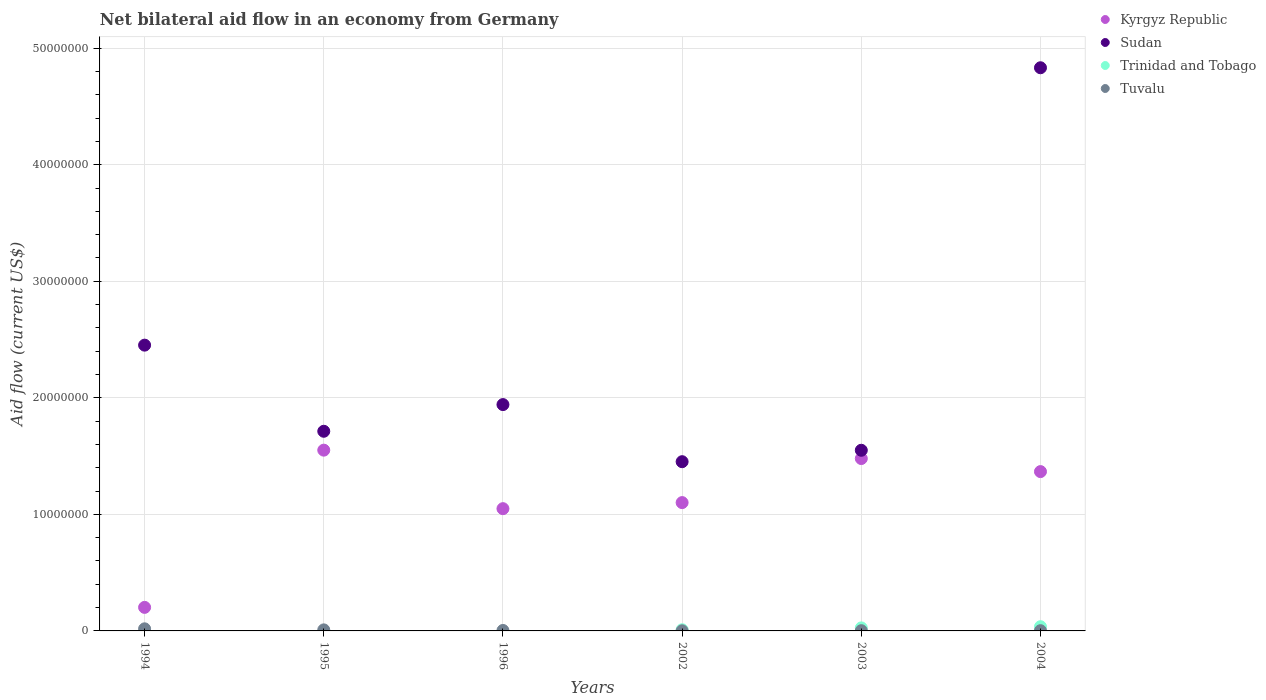Is the number of dotlines equal to the number of legend labels?
Provide a succinct answer. No. What is the net bilateral aid flow in Kyrgyz Republic in 2004?
Your answer should be very brief. 1.37e+07. Across all years, what is the maximum net bilateral aid flow in Sudan?
Give a very brief answer. 4.83e+07. Across all years, what is the minimum net bilateral aid flow in Kyrgyz Republic?
Keep it short and to the point. 2.02e+06. In which year was the net bilateral aid flow in Tuvalu maximum?
Provide a succinct answer. 1994. What is the difference between the net bilateral aid flow in Tuvalu in 2003 and that in 2004?
Your answer should be compact. 0. What is the difference between the net bilateral aid flow in Tuvalu in 1994 and the net bilateral aid flow in Sudan in 1996?
Offer a terse response. -1.92e+07. What is the average net bilateral aid flow in Sudan per year?
Give a very brief answer. 2.32e+07. In the year 1995, what is the difference between the net bilateral aid flow in Tuvalu and net bilateral aid flow in Sudan?
Your answer should be compact. -1.70e+07. What is the ratio of the net bilateral aid flow in Trinidad and Tobago in 2002 to that in 2004?
Your answer should be very brief. 0.28. Is the net bilateral aid flow in Sudan in 1995 less than that in 2003?
Offer a terse response. No. What is the difference between the highest and the second highest net bilateral aid flow in Sudan?
Your response must be concise. 2.38e+07. Is the sum of the net bilateral aid flow in Sudan in 1996 and 2004 greater than the maximum net bilateral aid flow in Trinidad and Tobago across all years?
Give a very brief answer. Yes. Does the net bilateral aid flow in Kyrgyz Republic monotonically increase over the years?
Offer a very short reply. No. Is the net bilateral aid flow in Tuvalu strictly less than the net bilateral aid flow in Trinidad and Tobago over the years?
Offer a very short reply. No. How many dotlines are there?
Provide a succinct answer. 4. How many years are there in the graph?
Your answer should be compact. 6. Where does the legend appear in the graph?
Keep it short and to the point. Top right. What is the title of the graph?
Your answer should be compact. Net bilateral aid flow in an economy from Germany. What is the label or title of the X-axis?
Offer a very short reply. Years. What is the Aid flow (current US$) of Kyrgyz Republic in 1994?
Make the answer very short. 2.02e+06. What is the Aid flow (current US$) in Sudan in 1994?
Your response must be concise. 2.45e+07. What is the Aid flow (current US$) in Trinidad and Tobago in 1994?
Keep it short and to the point. 0. What is the Aid flow (current US$) of Tuvalu in 1994?
Your answer should be compact. 1.80e+05. What is the Aid flow (current US$) in Kyrgyz Republic in 1995?
Your response must be concise. 1.55e+07. What is the Aid flow (current US$) of Sudan in 1995?
Offer a very short reply. 1.71e+07. What is the Aid flow (current US$) of Trinidad and Tobago in 1995?
Provide a short and direct response. 0. What is the Aid flow (current US$) in Tuvalu in 1995?
Offer a very short reply. 9.00e+04. What is the Aid flow (current US$) in Kyrgyz Republic in 1996?
Keep it short and to the point. 1.05e+07. What is the Aid flow (current US$) in Sudan in 1996?
Keep it short and to the point. 1.94e+07. What is the Aid flow (current US$) of Trinidad and Tobago in 1996?
Offer a terse response. 0. What is the Aid flow (current US$) in Kyrgyz Republic in 2002?
Your answer should be very brief. 1.10e+07. What is the Aid flow (current US$) of Sudan in 2002?
Ensure brevity in your answer.  1.45e+07. What is the Aid flow (current US$) in Trinidad and Tobago in 2002?
Provide a succinct answer. 1.00e+05. What is the Aid flow (current US$) in Tuvalu in 2002?
Offer a terse response. 10000. What is the Aid flow (current US$) of Kyrgyz Republic in 2003?
Offer a very short reply. 1.48e+07. What is the Aid flow (current US$) of Sudan in 2003?
Ensure brevity in your answer.  1.55e+07. What is the Aid flow (current US$) of Tuvalu in 2003?
Your answer should be compact. 2.00e+04. What is the Aid flow (current US$) in Kyrgyz Republic in 2004?
Offer a very short reply. 1.37e+07. What is the Aid flow (current US$) in Sudan in 2004?
Your answer should be compact. 4.83e+07. What is the Aid flow (current US$) of Trinidad and Tobago in 2004?
Provide a succinct answer. 3.60e+05. Across all years, what is the maximum Aid flow (current US$) of Kyrgyz Republic?
Give a very brief answer. 1.55e+07. Across all years, what is the maximum Aid flow (current US$) in Sudan?
Provide a short and direct response. 4.83e+07. Across all years, what is the maximum Aid flow (current US$) of Trinidad and Tobago?
Provide a short and direct response. 3.60e+05. Across all years, what is the maximum Aid flow (current US$) in Tuvalu?
Provide a short and direct response. 1.80e+05. Across all years, what is the minimum Aid flow (current US$) in Kyrgyz Republic?
Make the answer very short. 2.02e+06. Across all years, what is the minimum Aid flow (current US$) in Sudan?
Make the answer very short. 1.45e+07. Across all years, what is the minimum Aid flow (current US$) in Tuvalu?
Your answer should be very brief. 10000. What is the total Aid flow (current US$) in Kyrgyz Republic in the graph?
Give a very brief answer. 6.75e+07. What is the total Aid flow (current US$) in Sudan in the graph?
Keep it short and to the point. 1.39e+08. What is the total Aid flow (current US$) of Trinidad and Tobago in the graph?
Your response must be concise. 7.20e+05. What is the difference between the Aid flow (current US$) of Kyrgyz Republic in 1994 and that in 1995?
Your response must be concise. -1.35e+07. What is the difference between the Aid flow (current US$) of Sudan in 1994 and that in 1995?
Make the answer very short. 7.39e+06. What is the difference between the Aid flow (current US$) in Kyrgyz Republic in 1994 and that in 1996?
Keep it short and to the point. -8.47e+06. What is the difference between the Aid flow (current US$) of Sudan in 1994 and that in 1996?
Your answer should be very brief. 5.10e+06. What is the difference between the Aid flow (current US$) of Kyrgyz Republic in 1994 and that in 2002?
Your response must be concise. -8.99e+06. What is the difference between the Aid flow (current US$) of Sudan in 1994 and that in 2002?
Your answer should be compact. 1.00e+07. What is the difference between the Aid flow (current US$) in Tuvalu in 1994 and that in 2002?
Keep it short and to the point. 1.70e+05. What is the difference between the Aid flow (current US$) of Kyrgyz Republic in 1994 and that in 2003?
Your answer should be very brief. -1.28e+07. What is the difference between the Aid flow (current US$) of Sudan in 1994 and that in 2003?
Provide a succinct answer. 9.02e+06. What is the difference between the Aid flow (current US$) of Tuvalu in 1994 and that in 2003?
Ensure brevity in your answer.  1.60e+05. What is the difference between the Aid flow (current US$) in Kyrgyz Republic in 1994 and that in 2004?
Offer a very short reply. -1.16e+07. What is the difference between the Aid flow (current US$) in Sudan in 1994 and that in 2004?
Offer a terse response. -2.38e+07. What is the difference between the Aid flow (current US$) in Kyrgyz Republic in 1995 and that in 1996?
Keep it short and to the point. 5.02e+06. What is the difference between the Aid flow (current US$) of Sudan in 1995 and that in 1996?
Give a very brief answer. -2.29e+06. What is the difference between the Aid flow (current US$) of Tuvalu in 1995 and that in 1996?
Keep it short and to the point. 5.00e+04. What is the difference between the Aid flow (current US$) of Kyrgyz Republic in 1995 and that in 2002?
Your response must be concise. 4.50e+06. What is the difference between the Aid flow (current US$) of Sudan in 1995 and that in 2002?
Offer a terse response. 2.61e+06. What is the difference between the Aid flow (current US$) in Kyrgyz Republic in 1995 and that in 2003?
Ensure brevity in your answer.  7.20e+05. What is the difference between the Aid flow (current US$) of Sudan in 1995 and that in 2003?
Ensure brevity in your answer.  1.63e+06. What is the difference between the Aid flow (current US$) of Tuvalu in 1995 and that in 2003?
Your response must be concise. 7.00e+04. What is the difference between the Aid flow (current US$) of Kyrgyz Republic in 1995 and that in 2004?
Your answer should be compact. 1.84e+06. What is the difference between the Aid flow (current US$) of Sudan in 1995 and that in 2004?
Provide a succinct answer. -3.12e+07. What is the difference between the Aid flow (current US$) in Tuvalu in 1995 and that in 2004?
Your answer should be very brief. 7.00e+04. What is the difference between the Aid flow (current US$) in Kyrgyz Republic in 1996 and that in 2002?
Give a very brief answer. -5.20e+05. What is the difference between the Aid flow (current US$) of Sudan in 1996 and that in 2002?
Offer a very short reply. 4.90e+06. What is the difference between the Aid flow (current US$) of Kyrgyz Republic in 1996 and that in 2003?
Give a very brief answer. -4.30e+06. What is the difference between the Aid flow (current US$) of Sudan in 1996 and that in 2003?
Keep it short and to the point. 3.92e+06. What is the difference between the Aid flow (current US$) of Kyrgyz Republic in 1996 and that in 2004?
Keep it short and to the point. -3.18e+06. What is the difference between the Aid flow (current US$) in Sudan in 1996 and that in 2004?
Ensure brevity in your answer.  -2.89e+07. What is the difference between the Aid flow (current US$) in Kyrgyz Republic in 2002 and that in 2003?
Your answer should be compact. -3.78e+06. What is the difference between the Aid flow (current US$) in Sudan in 2002 and that in 2003?
Keep it short and to the point. -9.80e+05. What is the difference between the Aid flow (current US$) in Trinidad and Tobago in 2002 and that in 2003?
Keep it short and to the point. -1.60e+05. What is the difference between the Aid flow (current US$) in Kyrgyz Republic in 2002 and that in 2004?
Provide a short and direct response. -2.66e+06. What is the difference between the Aid flow (current US$) of Sudan in 2002 and that in 2004?
Provide a succinct answer. -3.38e+07. What is the difference between the Aid flow (current US$) in Trinidad and Tobago in 2002 and that in 2004?
Ensure brevity in your answer.  -2.60e+05. What is the difference between the Aid flow (current US$) of Kyrgyz Republic in 2003 and that in 2004?
Ensure brevity in your answer.  1.12e+06. What is the difference between the Aid flow (current US$) of Sudan in 2003 and that in 2004?
Provide a short and direct response. -3.28e+07. What is the difference between the Aid flow (current US$) in Trinidad and Tobago in 2003 and that in 2004?
Provide a succinct answer. -1.00e+05. What is the difference between the Aid flow (current US$) of Kyrgyz Republic in 1994 and the Aid flow (current US$) of Sudan in 1995?
Provide a succinct answer. -1.51e+07. What is the difference between the Aid flow (current US$) in Kyrgyz Republic in 1994 and the Aid flow (current US$) in Tuvalu in 1995?
Offer a terse response. 1.93e+06. What is the difference between the Aid flow (current US$) in Sudan in 1994 and the Aid flow (current US$) in Tuvalu in 1995?
Offer a very short reply. 2.44e+07. What is the difference between the Aid flow (current US$) in Kyrgyz Republic in 1994 and the Aid flow (current US$) in Sudan in 1996?
Give a very brief answer. -1.74e+07. What is the difference between the Aid flow (current US$) in Kyrgyz Republic in 1994 and the Aid flow (current US$) in Tuvalu in 1996?
Provide a short and direct response. 1.98e+06. What is the difference between the Aid flow (current US$) of Sudan in 1994 and the Aid flow (current US$) of Tuvalu in 1996?
Keep it short and to the point. 2.45e+07. What is the difference between the Aid flow (current US$) of Kyrgyz Republic in 1994 and the Aid flow (current US$) of Sudan in 2002?
Ensure brevity in your answer.  -1.25e+07. What is the difference between the Aid flow (current US$) in Kyrgyz Republic in 1994 and the Aid flow (current US$) in Trinidad and Tobago in 2002?
Your response must be concise. 1.92e+06. What is the difference between the Aid flow (current US$) of Kyrgyz Republic in 1994 and the Aid flow (current US$) of Tuvalu in 2002?
Provide a succinct answer. 2.01e+06. What is the difference between the Aid flow (current US$) in Sudan in 1994 and the Aid flow (current US$) in Trinidad and Tobago in 2002?
Your response must be concise. 2.44e+07. What is the difference between the Aid flow (current US$) of Sudan in 1994 and the Aid flow (current US$) of Tuvalu in 2002?
Offer a terse response. 2.45e+07. What is the difference between the Aid flow (current US$) in Kyrgyz Republic in 1994 and the Aid flow (current US$) in Sudan in 2003?
Your answer should be compact. -1.35e+07. What is the difference between the Aid flow (current US$) of Kyrgyz Republic in 1994 and the Aid flow (current US$) of Trinidad and Tobago in 2003?
Provide a short and direct response. 1.76e+06. What is the difference between the Aid flow (current US$) of Sudan in 1994 and the Aid flow (current US$) of Trinidad and Tobago in 2003?
Offer a terse response. 2.43e+07. What is the difference between the Aid flow (current US$) in Sudan in 1994 and the Aid flow (current US$) in Tuvalu in 2003?
Your answer should be compact. 2.45e+07. What is the difference between the Aid flow (current US$) in Kyrgyz Republic in 1994 and the Aid flow (current US$) in Sudan in 2004?
Give a very brief answer. -4.63e+07. What is the difference between the Aid flow (current US$) of Kyrgyz Republic in 1994 and the Aid flow (current US$) of Trinidad and Tobago in 2004?
Offer a very short reply. 1.66e+06. What is the difference between the Aid flow (current US$) of Kyrgyz Republic in 1994 and the Aid flow (current US$) of Tuvalu in 2004?
Make the answer very short. 2.00e+06. What is the difference between the Aid flow (current US$) of Sudan in 1994 and the Aid flow (current US$) of Trinidad and Tobago in 2004?
Make the answer very short. 2.42e+07. What is the difference between the Aid flow (current US$) of Sudan in 1994 and the Aid flow (current US$) of Tuvalu in 2004?
Offer a terse response. 2.45e+07. What is the difference between the Aid flow (current US$) of Kyrgyz Republic in 1995 and the Aid flow (current US$) of Sudan in 1996?
Ensure brevity in your answer.  -3.91e+06. What is the difference between the Aid flow (current US$) in Kyrgyz Republic in 1995 and the Aid flow (current US$) in Tuvalu in 1996?
Provide a short and direct response. 1.55e+07. What is the difference between the Aid flow (current US$) of Sudan in 1995 and the Aid flow (current US$) of Tuvalu in 1996?
Provide a succinct answer. 1.71e+07. What is the difference between the Aid flow (current US$) in Kyrgyz Republic in 1995 and the Aid flow (current US$) in Sudan in 2002?
Your answer should be compact. 9.90e+05. What is the difference between the Aid flow (current US$) in Kyrgyz Republic in 1995 and the Aid flow (current US$) in Trinidad and Tobago in 2002?
Provide a short and direct response. 1.54e+07. What is the difference between the Aid flow (current US$) in Kyrgyz Republic in 1995 and the Aid flow (current US$) in Tuvalu in 2002?
Keep it short and to the point. 1.55e+07. What is the difference between the Aid flow (current US$) in Sudan in 1995 and the Aid flow (current US$) in Trinidad and Tobago in 2002?
Ensure brevity in your answer.  1.70e+07. What is the difference between the Aid flow (current US$) of Sudan in 1995 and the Aid flow (current US$) of Tuvalu in 2002?
Keep it short and to the point. 1.71e+07. What is the difference between the Aid flow (current US$) in Kyrgyz Republic in 1995 and the Aid flow (current US$) in Trinidad and Tobago in 2003?
Offer a terse response. 1.52e+07. What is the difference between the Aid flow (current US$) of Kyrgyz Republic in 1995 and the Aid flow (current US$) of Tuvalu in 2003?
Ensure brevity in your answer.  1.55e+07. What is the difference between the Aid flow (current US$) in Sudan in 1995 and the Aid flow (current US$) in Trinidad and Tobago in 2003?
Offer a terse response. 1.69e+07. What is the difference between the Aid flow (current US$) of Sudan in 1995 and the Aid flow (current US$) of Tuvalu in 2003?
Your answer should be very brief. 1.71e+07. What is the difference between the Aid flow (current US$) of Kyrgyz Republic in 1995 and the Aid flow (current US$) of Sudan in 2004?
Provide a short and direct response. -3.28e+07. What is the difference between the Aid flow (current US$) of Kyrgyz Republic in 1995 and the Aid flow (current US$) of Trinidad and Tobago in 2004?
Make the answer very short. 1.52e+07. What is the difference between the Aid flow (current US$) of Kyrgyz Republic in 1995 and the Aid flow (current US$) of Tuvalu in 2004?
Offer a terse response. 1.55e+07. What is the difference between the Aid flow (current US$) in Sudan in 1995 and the Aid flow (current US$) in Trinidad and Tobago in 2004?
Provide a succinct answer. 1.68e+07. What is the difference between the Aid flow (current US$) of Sudan in 1995 and the Aid flow (current US$) of Tuvalu in 2004?
Make the answer very short. 1.71e+07. What is the difference between the Aid flow (current US$) of Kyrgyz Republic in 1996 and the Aid flow (current US$) of Sudan in 2002?
Make the answer very short. -4.03e+06. What is the difference between the Aid flow (current US$) of Kyrgyz Republic in 1996 and the Aid flow (current US$) of Trinidad and Tobago in 2002?
Ensure brevity in your answer.  1.04e+07. What is the difference between the Aid flow (current US$) of Kyrgyz Republic in 1996 and the Aid flow (current US$) of Tuvalu in 2002?
Make the answer very short. 1.05e+07. What is the difference between the Aid flow (current US$) in Sudan in 1996 and the Aid flow (current US$) in Trinidad and Tobago in 2002?
Keep it short and to the point. 1.93e+07. What is the difference between the Aid flow (current US$) of Sudan in 1996 and the Aid flow (current US$) of Tuvalu in 2002?
Make the answer very short. 1.94e+07. What is the difference between the Aid flow (current US$) in Kyrgyz Republic in 1996 and the Aid flow (current US$) in Sudan in 2003?
Provide a short and direct response. -5.01e+06. What is the difference between the Aid flow (current US$) in Kyrgyz Republic in 1996 and the Aid flow (current US$) in Trinidad and Tobago in 2003?
Your answer should be very brief. 1.02e+07. What is the difference between the Aid flow (current US$) in Kyrgyz Republic in 1996 and the Aid flow (current US$) in Tuvalu in 2003?
Provide a succinct answer. 1.05e+07. What is the difference between the Aid flow (current US$) in Sudan in 1996 and the Aid flow (current US$) in Trinidad and Tobago in 2003?
Offer a terse response. 1.92e+07. What is the difference between the Aid flow (current US$) in Sudan in 1996 and the Aid flow (current US$) in Tuvalu in 2003?
Your response must be concise. 1.94e+07. What is the difference between the Aid flow (current US$) of Kyrgyz Republic in 1996 and the Aid flow (current US$) of Sudan in 2004?
Your response must be concise. -3.78e+07. What is the difference between the Aid flow (current US$) of Kyrgyz Republic in 1996 and the Aid flow (current US$) of Trinidad and Tobago in 2004?
Your answer should be very brief. 1.01e+07. What is the difference between the Aid flow (current US$) of Kyrgyz Republic in 1996 and the Aid flow (current US$) of Tuvalu in 2004?
Provide a succinct answer. 1.05e+07. What is the difference between the Aid flow (current US$) of Sudan in 1996 and the Aid flow (current US$) of Trinidad and Tobago in 2004?
Keep it short and to the point. 1.91e+07. What is the difference between the Aid flow (current US$) in Sudan in 1996 and the Aid flow (current US$) in Tuvalu in 2004?
Offer a very short reply. 1.94e+07. What is the difference between the Aid flow (current US$) of Kyrgyz Republic in 2002 and the Aid flow (current US$) of Sudan in 2003?
Your response must be concise. -4.49e+06. What is the difference between the Aid flow (current US$) in Kyrgyz Republic in 2002 and the Aid flow (current US$) in Trinidad and Tobago in 2003?
Offer a terse response. 1.08e+07. What is the difference between the Aid flow (current US$) in Kyrgyz Republic in 2002 and the Aid flow (current US$) in Tuvalu in 2003?
Keep it short and to the point. 1.10e+07. What is the difference between the Aid flow (current US$) in Sudan in 2002 and the Aid flow (current US$) in Trinidad and Tobago in 2003?
Ensure brevity in your answer.  1.43e+07. What is the difference between the Aid flow (current US$) of Sudan in 2002 and the Aid flow (current US$) of Tuvalu in 2003?
Offer a very short reply. 1.45e+07. What is the difference between the Aid flow (current US$) of Trinidad and Tobago in 2002 and the Aid flow (current US$) of Tuvalu in 2003?
Your answer should be compact. 8.00e+04. What is the difference between the Aid flow (current US$) of Kyrgyz Republic in 2002 and the Aid flow (current US$) of Sudan in 2004?
Ensure brevity in your answer.  -3.73e+07. What is the difference between the Aid flow (current US$) of Kyrgyz Republic in 2002 and the Aid flow (current US$) of Trinidad and Tobago in 2004?
Make the answer very short. 1.06e+07. What is the difference between the Aid flow (current US$) in Kyrgyz Republic in 2002 and the Aid flow (current US$) in Tuvalu in 2004?
Ensure brevity in your answer.  1.10e+07. What is the difference between the Aid flow (current US$) of Sudan in 2002 and the Aid flow (current US$) of Trinidad and Tobago in 2004?
Your answer should be very brief. 1.42e+07. What is the difference between the Aid flow (current US$) in Sudan in 2002 and the Aid flow (current US$) in Tuvalu in 2004?
Provide a succinct answer. 1.45e+07. What is the difference between the Aid flow (current US$) in Kyrgyz Republic in 2003 and the Aid flow (current US$) in Sudan in 2004?
Your answer should be very brief. -3.35e+07. What is the difference between the Aid flow (current US$) in Kyrgyz Republic in 2003 and the Aid flow (current US$) in Trinidad and Tobago in 2004?
Your answer should be compact. 1.44e+07. What is the difference between the Aid flow (current US$) in Kyrgyz Republic in 2003 and the Aid flow (current US$) in Tuvalu in 2004?
Your answer should be very brief. 1.48e+07. What is the difference between the Aid flow (current US$) in Sudan in 2003 and the Aid flow (current US$) in Trinidad and Tobago in 2004?
Keep it short and to the point. 1.51e+07. What is the difference between the Aid flow (current US$) of Sudan in 2003 and the Aid flow (current US$) of Tuvalu in 2004?
Give a very brief answer. 1.55e+07. What is the difference between the Aid flow (current US$) in Trinidad and Tobago in 2003 and the Aid flow (current US$) in Tuvalu in 2004?
Make the answer very short. 2.40e+05. What is the average Aid flow (current US$) of Kyrgyz Republic per year?
Give a very brief answer. 1.12e+07. What is the average Aid flow (current US$) of Sudan per year?
Keep it short and to the point. 2.32e+07. What is the average Aid flow (current US$) in Trinidad and Tobago per year?
Your response must be concise. 1.20e+05. What is the average Aid flow (current US$) in Tuvalu per year?
Offer a very short reply. 6.00e+04. In the year 1994, what is the difference between the Aid flow (current US$) of Kyrgyz Republic and Aid flow (current US$) of Sudan?
Provide a short and direct response. -2.25e+07. In the year 1994, what is the difference between the Aid flow (current US$) in Kyrgyz Republic and Aid flow (current US$) in Tuvalu?
Ensure brevity in your answer.  1.84e+06. In the year 1994, what is the difference between the Aid flow (current US$) of Sudan and Aid flow (current US$) of Tuvalu?
Provide a short and direct response. 2.43e+07. In the year 1995, what is the difference between the Aid flow (current US$) in Kyrgyz Republic and Aid flow (current US$) in Sudan?
Give a very brief answer. -1.62e+06. In the year 1995, what is the difference between the Aid flow (current US$) of Kyrgyz Republic and Aid flow (current US$) of Tuvalu?
Keep it short and to the point. 1.54e+07. In the year 1995, what is the difference between the Aid flow (current US$) of Sudan and Aid flow (current US$) of Tuvalu?
Your answer should be very brief. 1.70e+07. In the year 1996, what is the difference between the Aid flow (current US$) of Kyrgyz Republic and Aid flow (current US$) of Sudan?
Offer a very short reply. -8.93e+06. In the year 1996, what is the difference between the Aid flow (current US$) of Kyrgyz Republic and Aid flow (current US$) of Tuvalu?
Offer a very short reply. 1.04e+07. In the year 1996, what is the difference between the Aid flow (current US$) of Sudan and Aid flow (current US$) of Tuvalu?
Offer a terse response. 1.94e+07. In the year 2002, what is the difference between the Aid flow (current US$) of Kyrgyz Republic and Aid flow (current US$) of Sudan?
Your answer should be compact. -3.51e+06. In the year 2002, what is the difference between the Aid flow (current US$) of Kyrgyz Republic and Aid flow (current US$) of Trinidad and Tobago?
Your answer should be very brief. 1.09e+07. In the year 2002, what is the difference between the Aid flow (current US$) in Kyrgyz Republic and Aid flow (current US$) in Tuvalu?
Your answer should be compact. 1.10e+07. In the year 2002, what is the difference between the Aid flow (current US$) in Sudan and Aid flow (current US$) in Trinidad and Tobago?
Your answer should be compact. 1.44e+07. In the year 2002, what is the difference between the Aid flow (current US$) of Sudan and Aid flow (current US$) of Tuvalu?
Provide a succinct answer. 1.45e+07. In the year 2003, what is the difference between the Aid flow (current US$) of Kyrgyz Republic and Aid flow (current US$) of Sudan?
Provide a short and direct response. -7.10e+05. In the year 2003, what is the difference between the Aid flow (current US$) of Kyrgyz Republic and Aid flow (current US$) of Trinidad and Tobago?
Offer a terse response. 1.45e+07. In the year 2003, what is the difference between the Aid flow (current US$) in Kyrgyz Republic and Aid flow (current US$) in Tuvalu?
Offer a terse response. 1.48e+07. In the year 2003, what is the difference between the Aid flow (current US$) in Sudan and Aid flow (current US$) in Trinidad and Tobago?
Provide a succinct answer. 1.52e+07. In the year 2003, what is the difference between the Aid flow (current US$) in Sudan and Aid flow (current US$) in Tuvalu?
Make the answer very short. 1.55e+07. In the year 2004, what is the difference between the Aid flow (current US$) of Kyrgyz Republic and Aid flow (current US$) of Sudan?
Offer a very short reply. -3.46e+07. In the year 2004, what is the difference between the Aid flow (current US$) in Kyrgyz Republic and Aid flow (current US$) in Trinidad and Tobago?
Keep it short and to the point. 1.33e+07. In the year 2004, what is the difference between the Aid flow (current US$) in Kyrgyz Republic and Aid flow (current US$) in Tuvalu?
Your answer should be very brief. 1.36e+07. In the year 2004, what is the difference between the Aid flow (current US$) in Sudan and Aid flow (current US$) in Trinidad and Tobago?
Your answer should be compact. 4.80e+07. In the year 2004, what is the difference between the Aid flow (current US$) in Sudan and Aid flow (current US$) in Tuvalu?
Your response must be concise. 4.83e+07. What is the ratio of the Aid flow (current US$) in Kyrgyz Republic in 1994 to that in 1995?
Make the answer very short. 0.13. What is the ratio of the Aid flow (current US$) in Sudan in 1994 to that in 1995?
Ensure brevity in your answer.  1.43. What is the ratio of the Aid flow (current US$) of Tuvalu in 1994 to that in 1995?
Your answer should be very brief. 2. What is the ratio of the Aid flow (current US$) in Kyrgyz Republic in 1994 to that in 1996?
Ensure brevity in your answer.  0.19. What is the ratio of the Aid flow (current US$) of Sudan in 1994 to that in 1996?
Your answer should be very brief. 1.26. What is the ratio of the Aid flow (current US$) in Kyrgyz Republic in 1994 to that in 2002?
Provide a succinct answer. 0.18. What is the ratio of the Aid flow (current US$) of Sudan in 1994 to that in 2002?
Keep it short and to the point. 1.69. What is the ratio of the Aid flow (current US$) of Kyrgyz Republic in 1994 to that in 2003?
Ensure brevity in your answer.  0.14. What is the ratio of the Aid flow (current US$) in Sudan in 1994 to that in 2003?
Make the answer very short. 1.58. What is the ratio of the Aid flow (current US$) in Tuvalu in 1994 to that in 2003?
Your response must be concise. 9. What is the ratio of the Aid flow (current US$) in Kyrgyz Republic in 1994 to that in 2004?
Make the answer very short. 0.15. What is the ratio of the Aid flow (current US$) of Sudan in 1994 to that in 2004?
Offer a very short reply. 0.51. What is the ratio of the Aid flow (current US$) in Tuvalu in 1994 to that in 2004?
Provide a short and direct response. 9. What is the ratio of the Aid flow (current US$) of Kyrgyz Republic in 1995 to that in 1996?
Provide a short and direct response. 1.48. What is the ratio of the Aid flow (current US$) of Sudan in 1995 to that in 1996?
Your answer should be very brief. 0.88. What is the ratio of the Aid flow (current US$) in Tuvalu in 1995 to that in 1996?
Offer a very short reply. 2.25. What is the ratio of the Aid flow (current US$) of Kyrgyz Republic in 1995 to that in 2002?
Make the answer very short. 1.41. What is the ratio of the Aid flow (current US$) in Sudan in 1995 to that in 2002?
Give a very brief answer. 1.18. What is the ratio of the Aid flow (current US$) in Kyrgyz Republic in 1995 to that in 2003?
Give a very brief answer. 1.05. What is the ratio of the Aid flow (current US$) of Sudan in 1995 to that in 2003?
Your answer should be very brief. 1.11. What is the ratio of the Aid flow (current US$) in Kyrgyz Republic in 1995 to that in 2004?
Your response must be concise. 1.13. What is the ratio of the Aid flow (current US$) in Sudan in 1995 to that in 2004?
Provide a short and direct response. 0.35. What is the ratio of the Aid flow (current US$) of Tuvalu in 1995 to that in 2004?
Your response must be concise. 4.5. What is the ratio of the Aid flow (current US$) of Kyrgyz Republic in 1996 to that in 2002?
Your answer should be compact. 0.95. What is the ratio of the Aid flow (current US$) of Sudan in 1996 to that in 2002?
Your answer should be compact. 1.34. What is the ratio of the Aid flow (current US$) of Tuvalu in 1996 to that in 2002?
Provide a succinct answer. 4. What is the ratio of the Aid flow (current US$) of Kyrgyz Republic in 1996 to that in 2003?
Ensure brevity in your answer.  0.71. What is the ratio of the Aid flow (current US$) in Sudan in 1996 to that in 2003?
Make the answer very short. 1.25. What is the ratio of the Aid flow (current US$) in Tuvalu in 1996 to that in 2003?
Provide a short and direct response. 2. What is the ratio of the Aid flow (current US$) in Kyrgyz Republic in 1996 to that in 2004?
Offer a very short reply. 0.77. What is the ratio of the Aid flow (current US$) in Sudan in 1996 to that in 2004?
Offer a terse response. 0.4. What is the ratio of the Aid flow (current US$) of Tuvalu in 1996 to that in 2004?
Make the answer very short. 2. What is the ratio of the Aid flow (current US$) of Kyrgyz Republic in 2002 to that in 2003?
Provide a succinct answer. 0.74. What is the ratio of the Aid flow (current US$) of Sudan in 2002 to that in 2003?
Ensure brevity in your answer.  0.94. What is the ratio of the Aid flow (current US$) in Trinidad and Tobago in 2002 to that in 2003?
Provide a succinct answer. 0.38. What is the ratio of the Aid flow (current US$) of Kyrgyz Republic in 2002 to that in 2004?
Provide a succinct answer. 0.81. What is the ratio of the Aid flow (current US$) of Sudan in 2002 to that in 2004?
Offer a terse response. 0.3. What is the ratio of the Aid flow (current US$) in Trinidad and Tobago in 2002 to that in 2004?
Your answer should be compact. 0.28. What is the ratio of the Aid flow (current US$) in Kyrgyz Republic in 2003 to that in 2004?
Make the answer very short. 1.08. What is the ratio of the Aid flow (current US$) of Sudan in 2003 to that in 2004?
Make the answer very short. 0.32. What is the ratio of the Aid flow (current US$) of Trinidad and Tobago in 2003 to that in 2004?
Ensure brevity in your answer.  0.72. What is the ratio of the Aid flow (current US$) of Tuvalu in 2003 to that in 2004?
Offer a terse response. 1. What is the difference between the highest and the second highest Aid flow (current US$) of Kyrgyz Republic?
Your response must be concise. 7.20e+05. What is the difference between the highest and the second highest Aid flow (current US$) in Sudan?
Your response must be concise. 2.38e+07. What is the difference between the highest and the second highest Aid flow (current US$) in Trinidad and Tobago?
Your answer should be compact. 1.00e+05. What is the difference between the highest and the lowest Aid flow (current US$) in Kyrgyz Republic?
Ensure brevity in your answer.  1.35e+07. What is the difference between the highest and the lowest Aid flow (current US$) of Sudan?
Your response must be concise. 3.38e+07. What is the difference between the highest and the lowest Aid flow (current US$) in Trinidad and Tobago?
Give a very brief answer. 3.60e+05. 